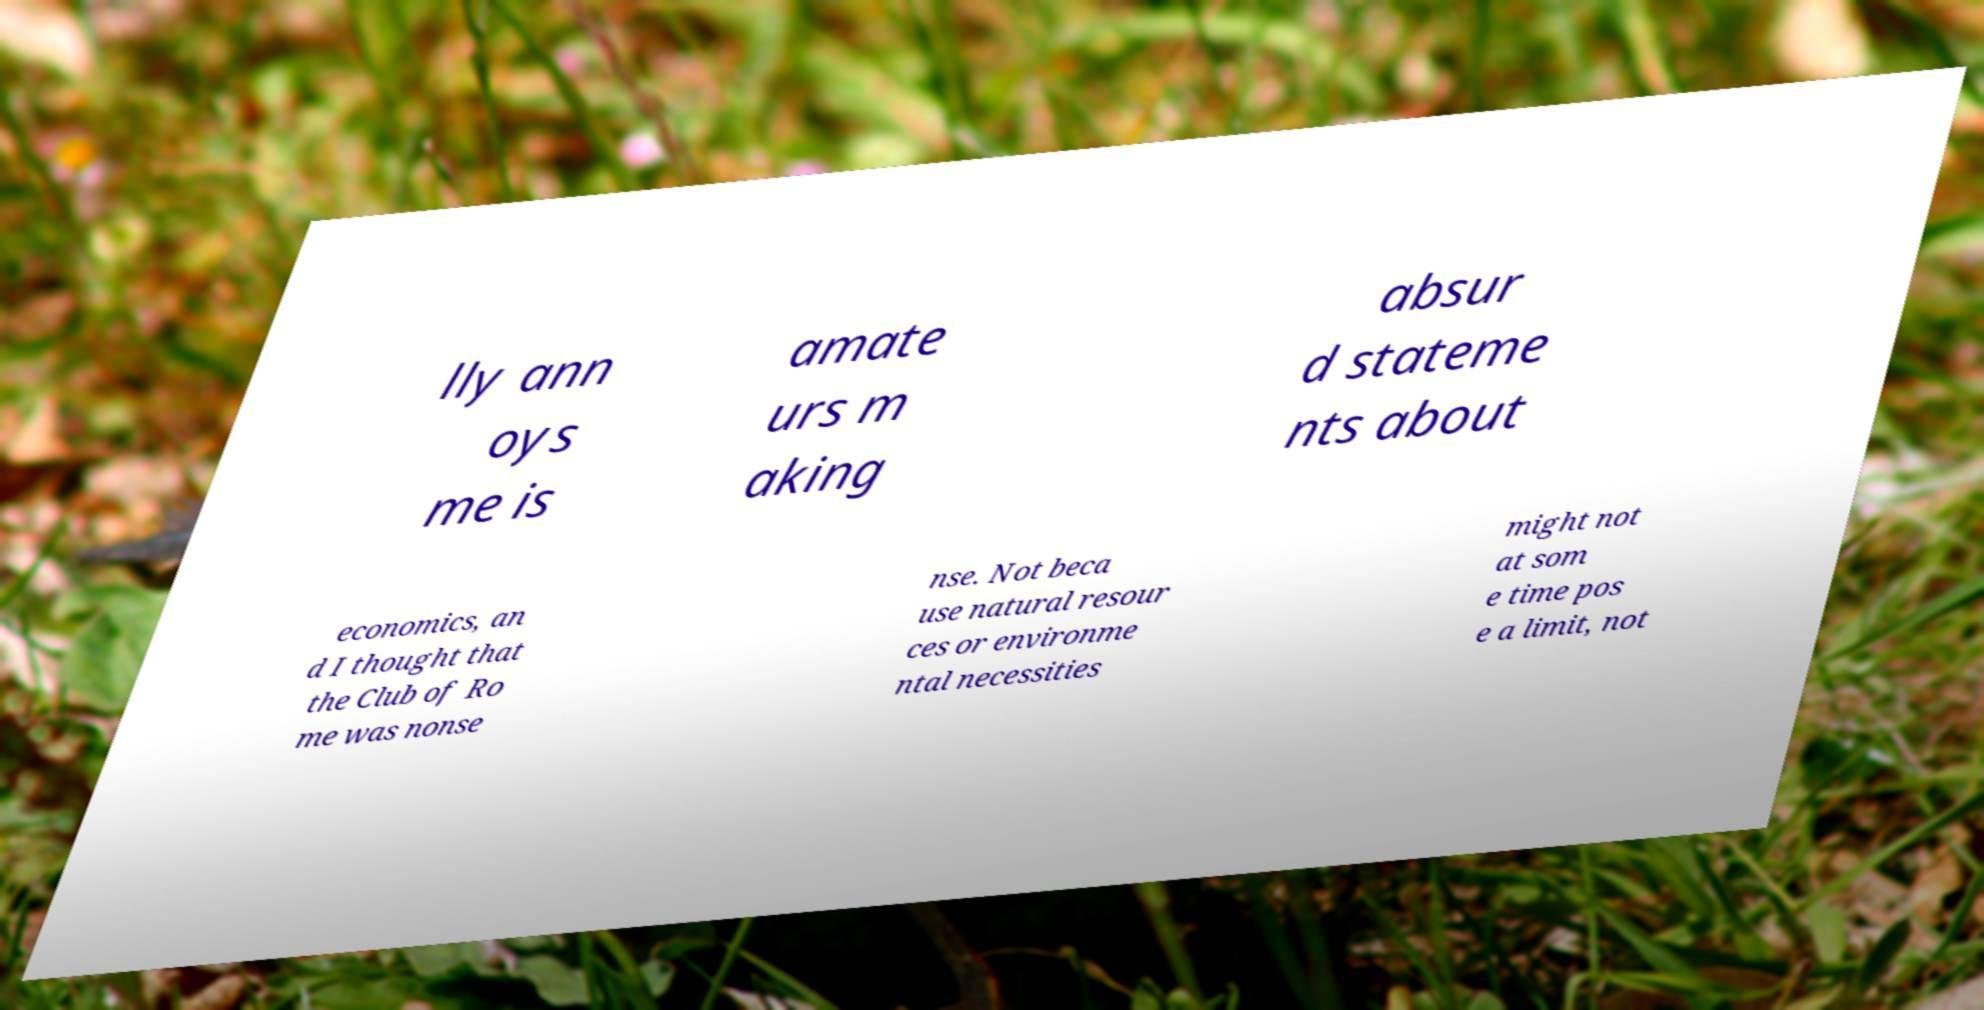Could you assist in decoding the text presented in this image and type it out clearly? lly ann oys me is amate urs m aking absur d stateme nts about economics, an d I thought that the Club of Ro me was nonse nse. Not beca use natural resour ces or environme ntal necessities might not at som e time pos e a limit, not 